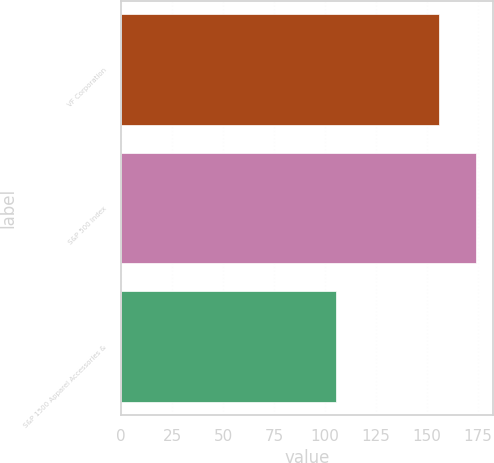Convert chart to OTSL. <chart><loc_0><loc_0><loc_500><loc_500><bar_chart><fcel>VF Corporation<fcel>S&P 500 Index<fcel>S&P 1500 Apparel Accessories &<nl><fcel>155.86<fcel>173.74<fcel>105.25<nl></chart> 